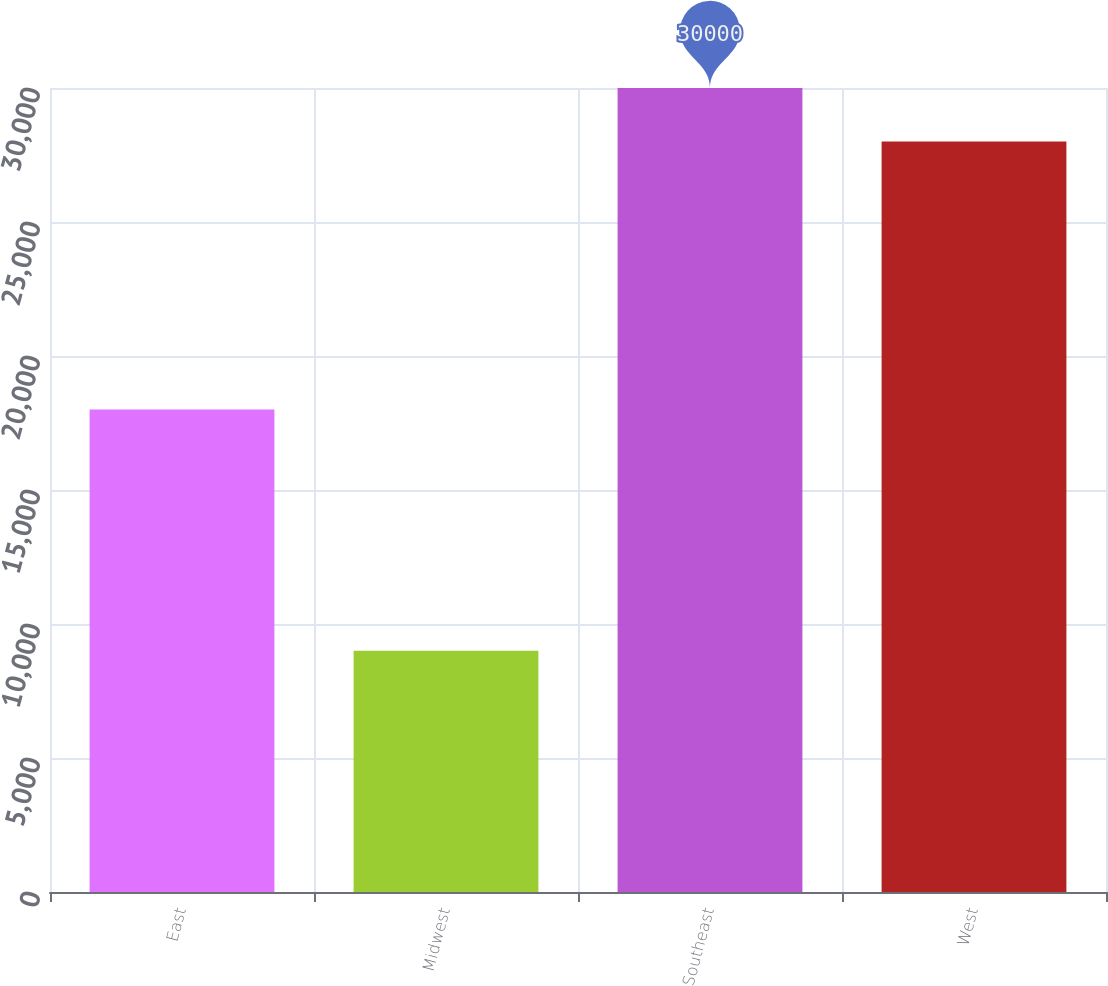<chart> <loc_0><loc_0><loc_500><loc_500><bar_chart><fcel>East<fcel>Midwest<fcel>Southeast<fcel>West<nl><fcel>18000<fcel>9000<fcel>30000<fcel>28000<nl></chart> 